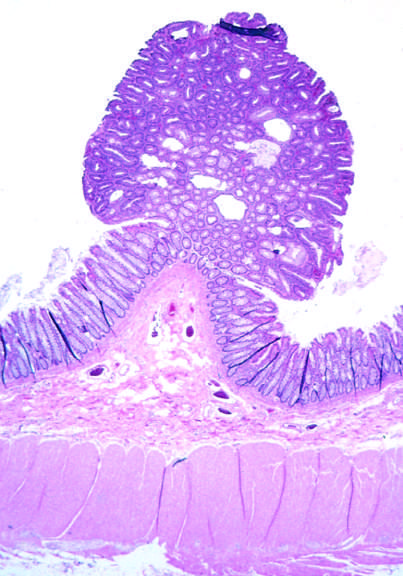re small nests of epithelial cells and myxoid stroma forming cartilage and bone presented in this field?
Answer the question using a single word or phrase. Yes 